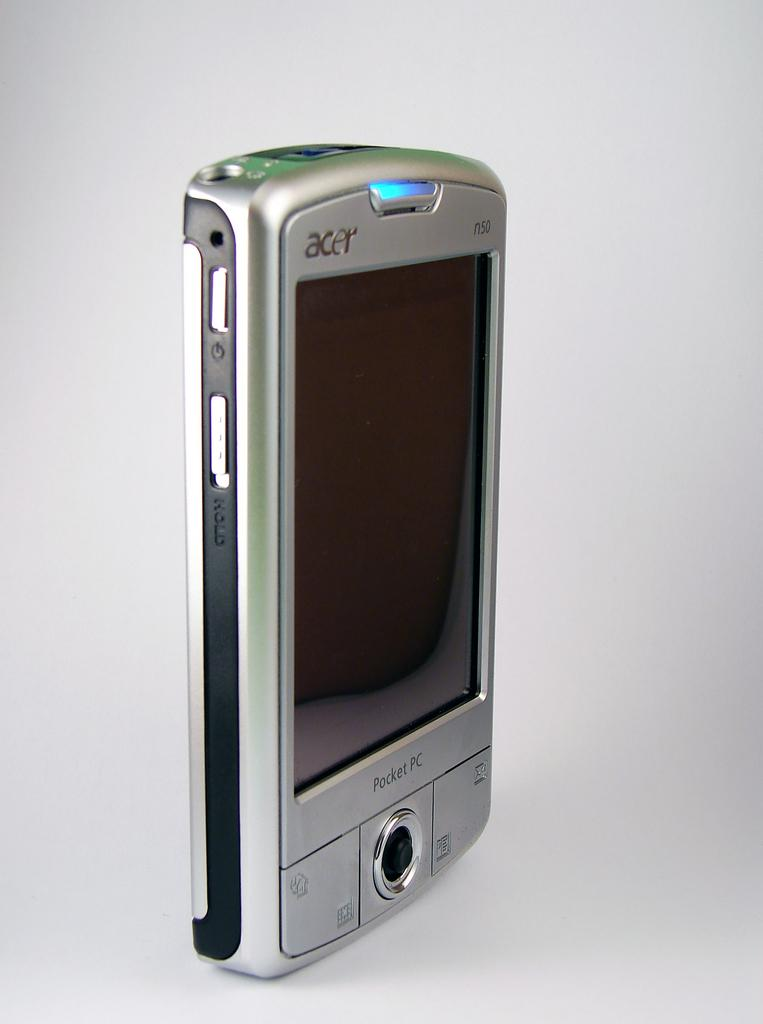What type of device is shown in the image? There is a mobile phone in the image. Which company manufactures the mobile phone? The mobile phone is from the Acer company. What part of the mobile phone is visible in the image? The image shows the screen of the mobile phone. Are there any physical controls visible on the mobile phone? Yes, there are buttons visible on the mobile phone. What color is the background of the image? The background of the image appears to be white. What is the mobile phone's thought process during its journey in the image? The mobile phone does not have a thought process, as it is an inanimate object. Additionally, the concept of a "journey" does not apply to a mobile phone in an image. 